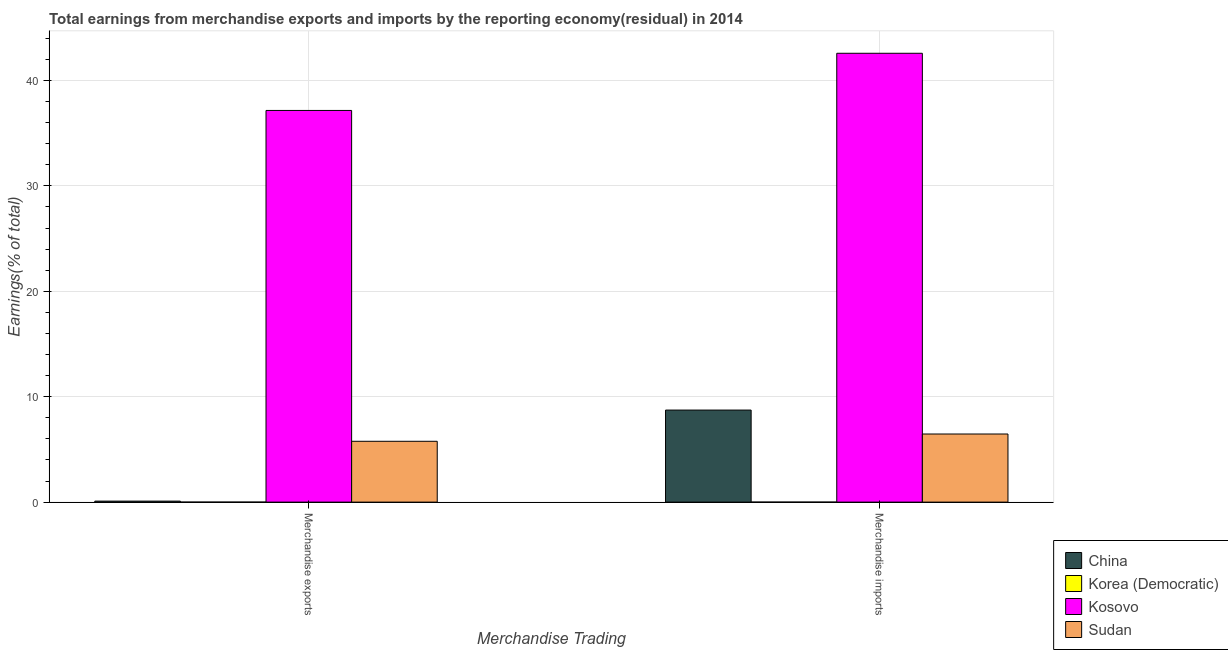How many groups of bars are there?
Your answer should be very brief. 2. What is the earnings from merchandise imports in Sudan?
Make the answer very short. 6.46. Across all countries, what is the maximum earnings from merchandise exports?
Your response must be concise. 37.15. Across all countries, what is the minimum earnings from merchandise imports?
Offer a very short reply. 0. In which country was the earnings from merchandise imports maximum?
Offer a very short reply. Kosovo. What is the total earnings from merchandise exports in the graph?
Offer a very short reply. 43.02. What is the difference between the earnings from merchandise imports in Sudan and that in China?
Provide a short and direct response. -2.27. What is the difference between the earnings from merchandise exports in Korea (Democratic) and the earnings from merchandise imports in China?
Offer a very short reply. -8.73. What is the average earnings from merchandise exports per country?
Offer a terse response. 10.75. What is the difference between the earnings from merchandise exports and earnings from merchandise imports in Sudan?
Ensure brevity in your answer.  -0.69. In how many countries, is the earnings from merchandise imports greater than 24 %?
Your answer should be very brief. 1. What is the ratio of the earnings from merchandise exports in China to that in Kosovo?
Offer a very short reply. 0. Is the earnings from merchandise exports in Sudan less than that in China?
Your answer should be compact. No. In how many countries, is the earnings from merchandise exports greater than the average earnings from merchandise exports taken over all countries?
Provide a short and direct response. 1. How many bars are there?
Provide a short and direct response. 6. How many countries are there in the graph?
Offer a terse response. 4. What is the difference between two consecutive major ticks on the Y-axis?
Your answer should be very brief. 10. Are the values on the major ticks of Y-axis written in scientific E-notation?
Ensure brevity in your answer.  No. Does the graph contain any zero values?
Keep it short and to the point. Yes. Where does the legend appear in the graph?
Provide a succinct answer. Bottom right. What is the title of the graph?
Keep it short and to the point. Total earnings from merchandise exports and imports by the reporting economy(residual) in 2014. Does "Trinidad and Tobago" appear as one of the legend labels in the graph?
Provide a short and direct response. No. What is the label or title of the X-axis?
Provide a short and direct response. Merchandise Trading. What is the label or title of the Y-axis?
Provide a succinct answer. Earnings(% of total). What is the Earnings(% of total) in China in Merchandise exports?
Your answer should be very brief. 0.1. What is the Earnings(% of total) in Korea (Democratic) in Merchandise exports?
Make the answer very short. 0. What is the Earnings(% of total) in Kosovo in Merchandise exports?
Offer a terse response. 37.15. What is the Earnings(% of total) of Sudan in Merchandise exports?
Make the answer very short. 5.77. What is the Earnings(% of total) in China in Merchandise imports?
Offer a very short reply. 8.73. What is the Earnings(% of total) in Korea (Democratic) in Merchandise imports?
Keep it short and to the point. 0. What is the Earnings(% of total) of Kosovo in Merchandise imports?
Make the answer very short. 42.57. What is the Earnings(% of total) of Sudan in Merchandise imports?
Make the answer very short. 6.46. Across all Merchandise Trading, what is the maximum Earnings(% of total) of China?
Make the answer very short. 8.73. Across all Merchandise Trading, what is the maximum Earnings(% of total) in Kosovo?
Give a very brief answer. 42.57. Across all Merchandise Trading, what is the maximum Earnings(% of total) of Sudan?
Make the answer very short. 6.46. Across all Merchandise Trading, what is the minimum Earnings(% of total) in China?
Make the answer very short. 0.1. Across all Merchandise Trading, what is the minimum Earnings(% of total) of Kosovo?
Provide a succinct answer. 37.15. Across all Merchandise Trading, what is the minimum Earnings(% of total) of Sudan?
Provide a succinct answer. 5.77. What is the total Earnings(% of total) of China in the graph?
Your response must be concise. 8.83. What is the total Earnings(% of total) in Korea (Democratic) in the graph?
Your answer should be compact. 0. What is the total Earnings(% of total) in Kosovo in the graph?
Your response must be concise. 79.72. What is the total Earnings(% of total) in Sudan in the graph?
Offer a terse response. 12.23. What is the difference between the Earnings(% of total) of China in Merchandise exports and that in Merchandise imports?
Offer a terse response. -8.64. What is the difference between the Earnings(% of total) in Kosovo in Merchandise exports and that in Merchandise imports?
Keep it short and to the point. -5.42. What is the difference between the Earnings(% of total) in Sudan in Merchandise exports and that in Merchandise imports?
Ensure brevity in your answer.  -0.69. What is the difference between the Earnings(% of total) of China in Merchandise exports and the Earnings(% of total) of Kosovo in Merchandise imports?
Your answer should be very brief. -42.48. What is the difference between the Earnings(% of total) of China in Merchandise exports and the Earnings(% of total) of Sudan in Merchandise imports?
Your answer should be compact. -6.36. What is the difference between the Earnings(% of total) in Kosovo in Merchandise exports and the Earnings(% of total) in Sudan in Merchandise imports?
Offer a very short reply. 30.69. What is the average Earnings(% of total) of China per Merchandise Trading?
Ensure brevity in your answer.  4.41. What is the average Earnings(% of total) of Korea (Democratic) per Merchandise Trading?
Offer a terse response. 0. What is the average Earnings(% of total) in Kosovo per Merchandise Trading?
Make the answer very short. 39.86. What is the average Earnings(% of total) in Sudan per Merchandise Trading?
Ensure brevity in your answer.  6.12. What is the difference between the Earnings(% of total) in China and Earnings(% of total) in Kosovo in Merchandise exports?
Your answer should be very brief. -37.05. What is the difference between the Earnings(% of total) in China and Earnings(% of total) in Sudan in Merchandise exports?
Keep it short and to the point. -5.67. What is the difference between the Earnings(% of total) in Kosovo and Earnings(% of total) in Sudan in Merchandise exports?
Your answer should be very brief. 31.38. What is the difference between the Earnings(% of total) in China and Earnings(% of total) in Kosovo in Merchandise imports?
Your answer should be very brief. -33.84. What is the difference between the Earnings(% of total) of China and Earnings(% of total) of Sudan in Merchandise imports?
Provide a short and direct response. 2.27. What is the difference between the Earnings(% of total) of Kosovo and Earnings(% of total) of Sudan in Merchandise imports?
Ensure brevity in your answer.  36.11. What is the ratio of the Earnings(% of total) of China in Merchandise exports to that in Merchandise imports?
Your answer should be compact. 0.01. What is the ratio of the Earnings(% of total) of Kosovo in Merchandise exports to that in Merchandise imports?
Your answer should be compact. 0.87. What is the ratio of the Earnings(% of total) of Sudan in Merchandise exports to that in Merchandise imports?
Ensure brevity in your answer.  0.89. What is the difference between the highest and the second highest Earnings(% of total) in China?
Provide a short and direct response. 8.64. What is the difference between the highest and the second highest Earnings(% of total) of Kosovo?
Your answer should be compact. 5.42. What is the difference between the highest and the second highest Earnings(% of total) of Sudan?
Offer a very short reply. 0.69. What is the difference between the highest and the lowest Earnings(% of total) of China?
Your response must be concise. 8.64. What is the difference between the highest and the lowest Earnings(% of total) of Kosovo?
Provide a succinct answer. 5.42. What is the difference between the highest and the lowest Earnings(% of total) in Sudan?
Offer a terse response. 0.69. 